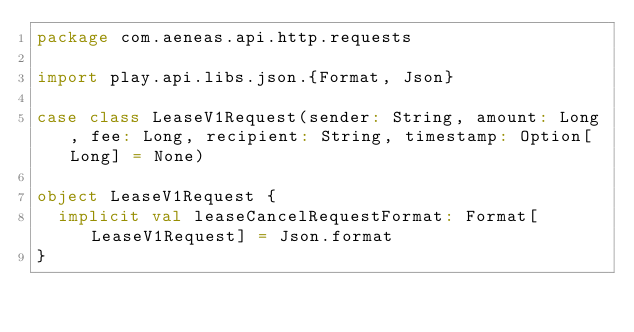<code> <loc_0><loc_0><loc_500><loc_500><_Scala_>package com.aeneas.api.http.requests

import play.api.libs.json.{Format, Json}

case class LeaseV1Request(sender: String, amount: Long, fee: Long, recipient: String, timestamp: Option[Long] = None)

object LeaseV1Request {
  implicit val leaseCancelRequestFormat: Format[LeaseV1Request] = Json.format
}
</code> 